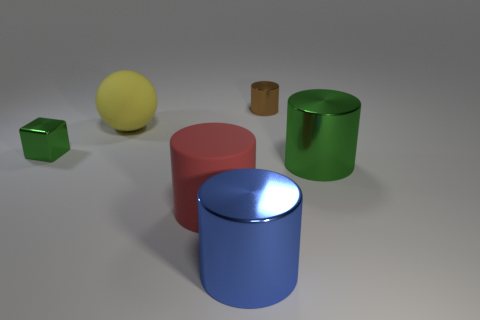Add 3 tiny cyan matte blocks. How many objects exist? 9 Subtract all cylinders. How many objects are left? 2 Add 4 blue shiny cylinders. How many blue shiny cylinders exist? 5 Subtract 1 brown cylinders. How many objects are left? 5 Subtract all blue shiny things. Subtract all small metallic cubes. How many objects are left? 4 Add 1 blue metal cylinders. How many blue metal cylinders are left? 2 